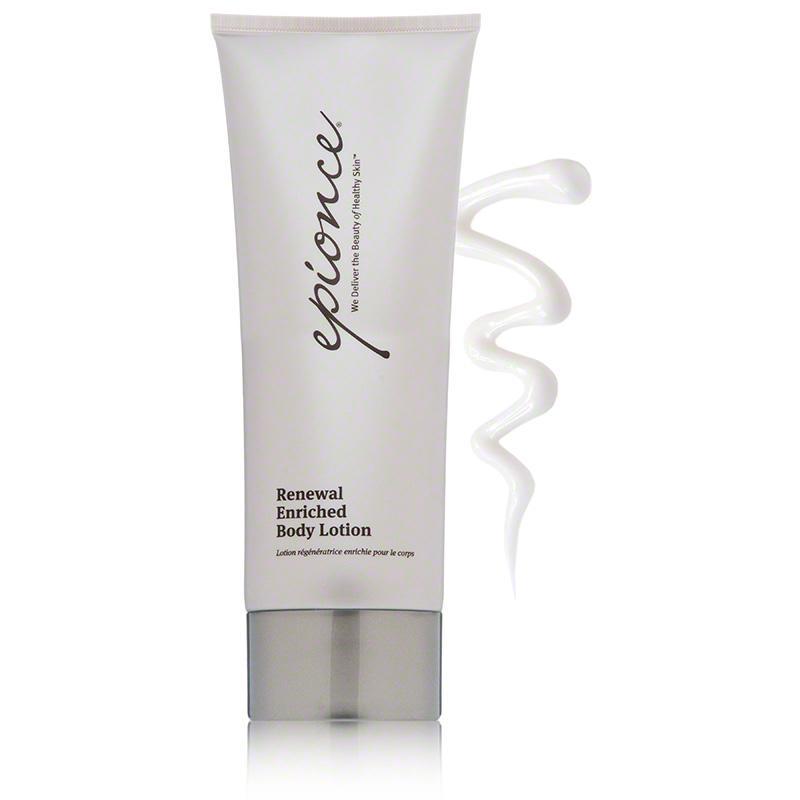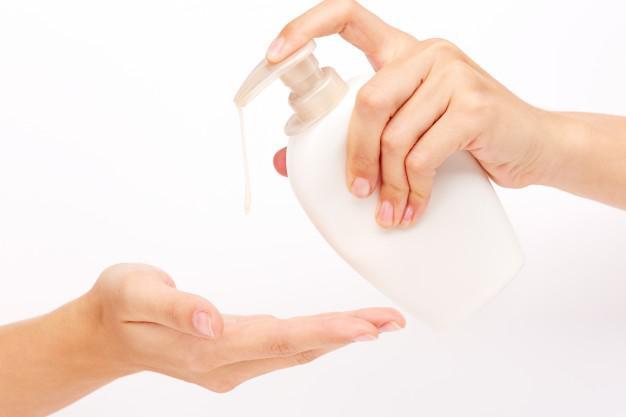The first image is the image on the left, the second image is the image on the right. Examine the images to the left and right. Is the description "One image shows the finger of one hand pressing the top of a white bottle to squirt lotion on another hand." accurate? Answer yes or no. Yes. 